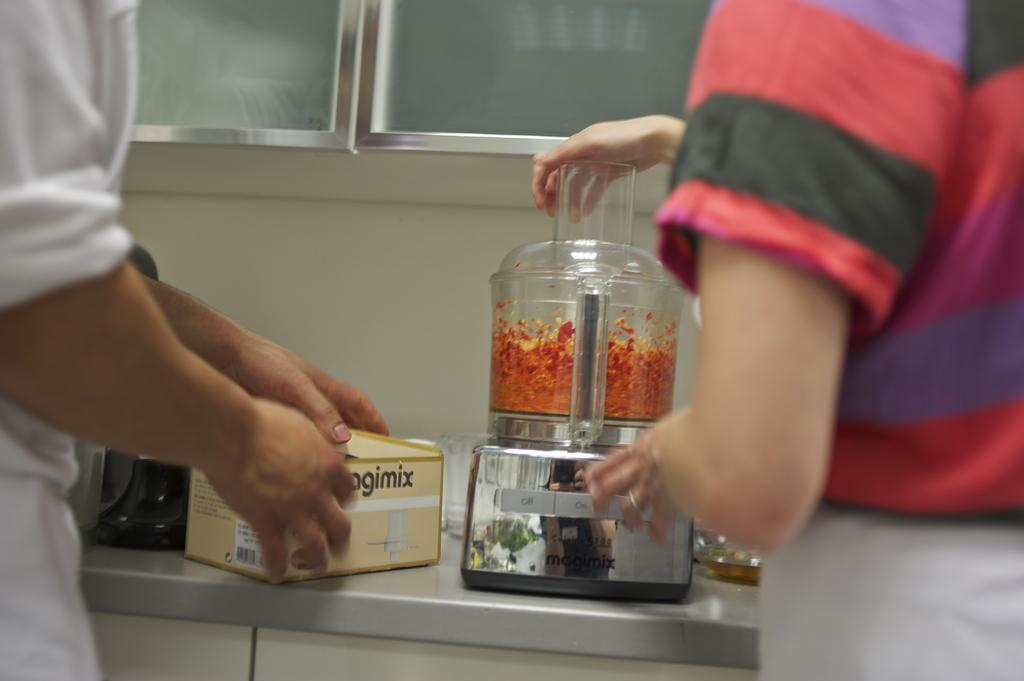<image>
Relay a brief, clear account of the picture shown. Two people using a Mogimix food processor in the kitchen. 